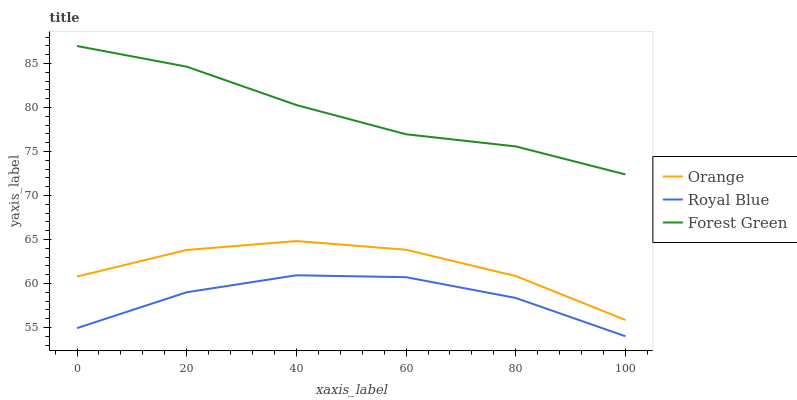Does Royal Blue have the minimum area under the curve?
Answer yes or no. Yes. Does Forest Green have the maximum area under the curve?
Answer yes or no. Yes. Does Forest Green have the minimum area under the curve?
Answer yes or no. No. Does Royal Blue have the maximum area under the curve?
Answer yes or no. No. Is Forest Green the smoothest?
Answer yes or no. Yes. Is Royal Blue the roughest?
Answer yes or no. Yes. Is Royal Blue the smoothest?
Answer yes or no. No. Is Forest Green the roughest?
Answer yes or no. No. Does Royal Blue have the lowest value?
Answer yes or no. Yes. Does Forest Green have the lowest value?
Answer yes or no. No. Does Forest Green have the highest value?
Answer yes or no. Yes. Does Royal Blue have the highest value?
Answer yes or no. No. Is Royal Blue less than Orange?
Answer yes or no. Yes. Is Orange greater than Royal Blue?
Answer yes or no. Yes. Does Royal Blue intersect Orange?
Answer yes or no. No. 